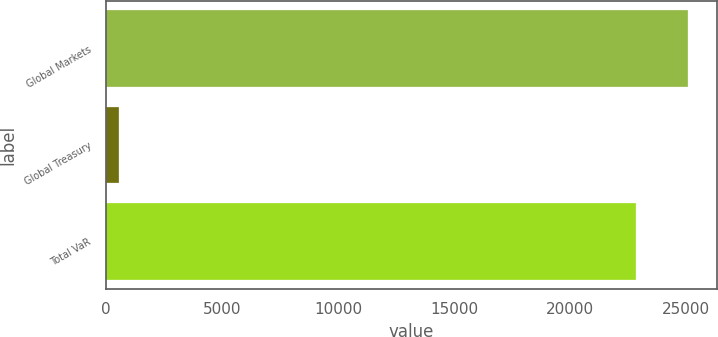Convert chart to OTSL. <chart><loc_0><loc_0><loc_500><loc_500><bar_chart><fcel>Global Markets<fcel>Global Treasury<fcel>Total VaR<nl><fcel>25061.6<fcel>559<fcel>22834<nl></chart> 